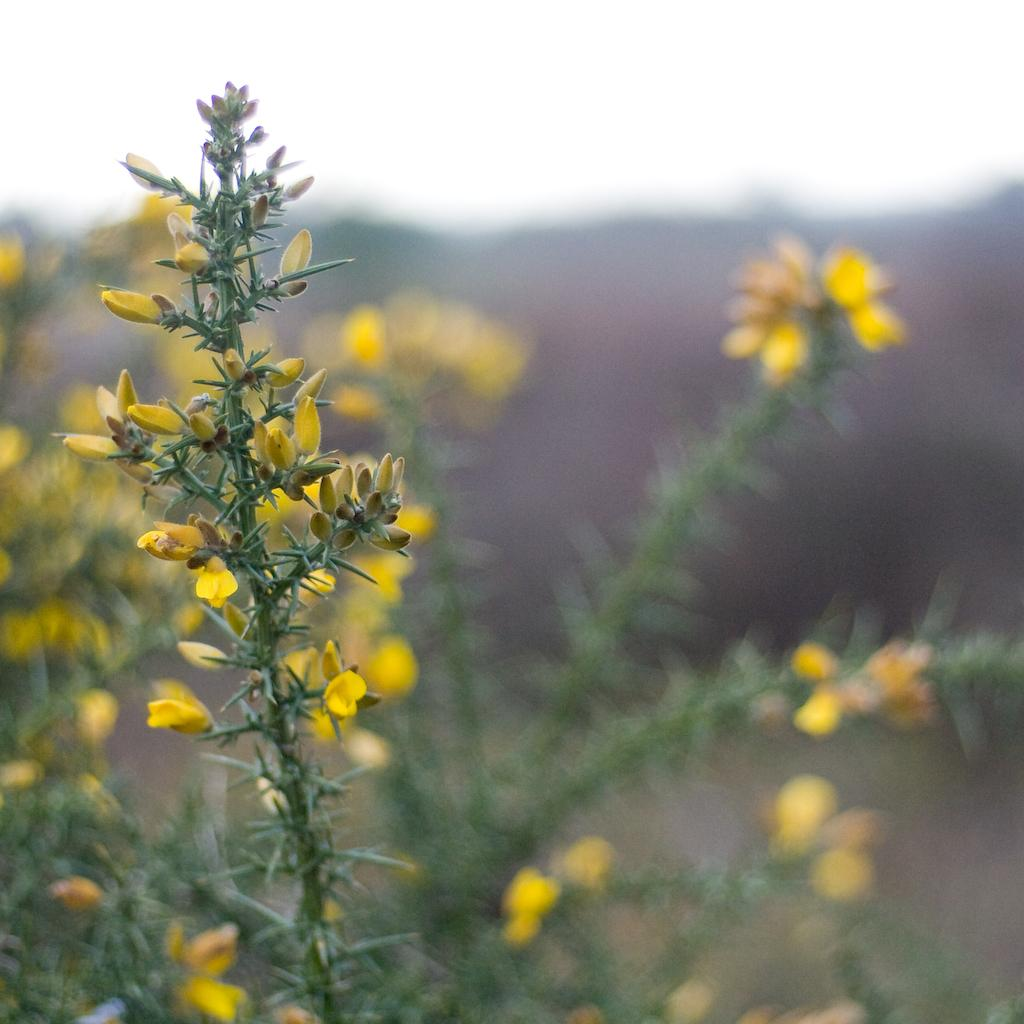What type of plants can be seen in the image? There are plants with flowers in the image. What stage of growth are the plants in? The plants have buds. What is the condition of the background in the image? The background of the image is blurry. What is visible at the top of the image? The sky is visible at the top of the image. What color is the dress worn by the house in the image? There is no house or dress present in the image; it features plants with flowers and a blurry background. 